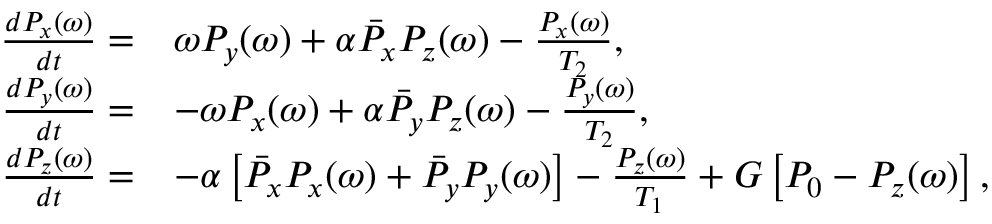Convert formula to latex. <formula><loc_0><loc_0><loc_500><loc_500>\begin{array} { r l } { \frac { d P _ { x } ( \omega ) } { d t } = } & { \omega P _ { y } ( \omega ) + \alpha \bar { P } _ { x } P _ { z } ( \omega ) - \frac { P _ { x } ( \omega ) } { T _ { 2 } } , } \\ { \frac { d P _ { y } ( \omega ) } { d t } = } & { - \omega P _ { x } ( \omega ) + \alpha \bar { P } _ { y } P _ { z } ( \omega ) - \frac { P _ { y } ( \omega ) } { T _ { 2 } } , } \\ { \frac { d P _ { z } ( \omega ) } { d t } = } & { - \alpha \left [ \bar { P } _ { x } P _ { x } ( \omega ) + \bar { P } _ { y } P _ { y } ( \omega ) \right ] - \frac { P _ { z } ( \omega ) } { T _ { 1 } } + G \left [ P _ { 0 } - P _ { z } ( \omega ) \right ] , } \end{array}</formula> 